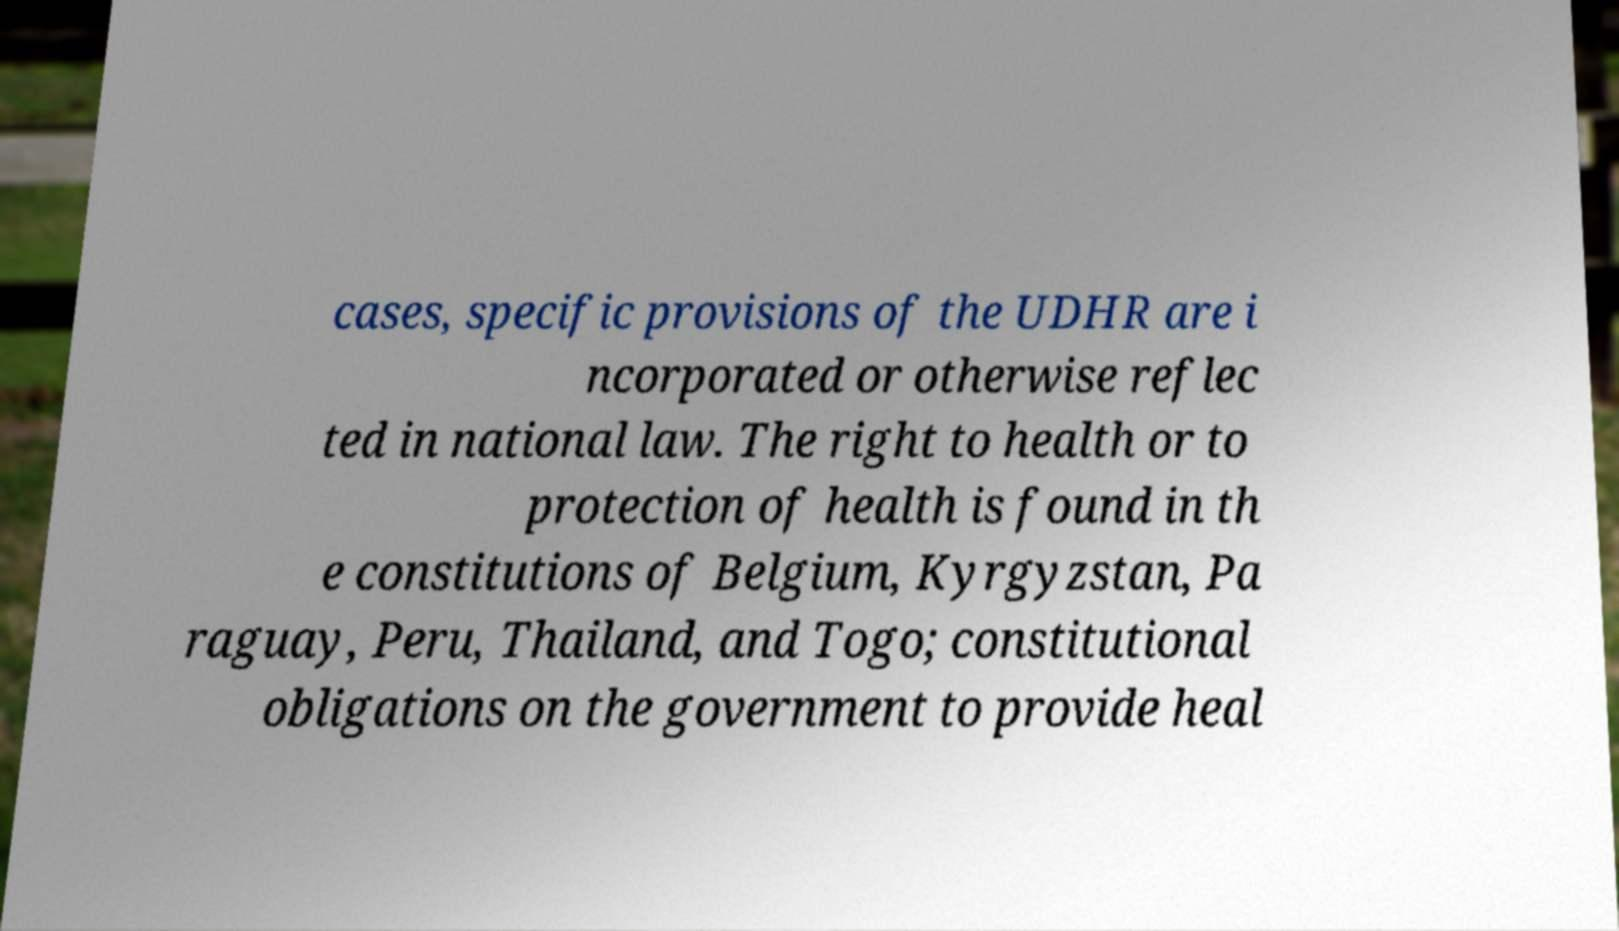Please identify and transcribe the text found in this image. cases, specific provisions of the UDHR are i ncorporated or otherwise reflec ted in national law. The right to health or to protection of health is found in th e constitutions of Belgium, Kyrgyzstan, Pa raguay, Peru, Thailand, and Togo; constitutional obligations on the government to provide heal 